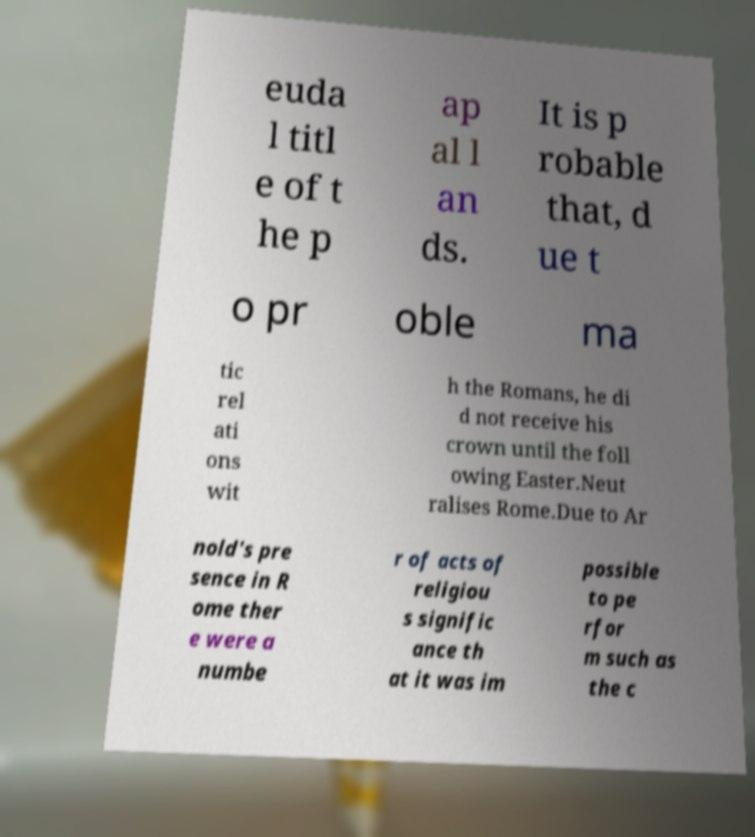Could you assist in decoding the text presented in this image and type it out clearly? euda l titl e of t he p ap al l an ds. It is p robable that, d ue t o pr oble ma tic rel ati ons wit h the Romans, he di d not receive his crown until the foll owing Easter.Neut ralises Rome.Due to Ar nold's pre sence in R ome ther e were a numbe r of acts of religiou s signific ance th at it was im possible to pe rfor m such as the c 